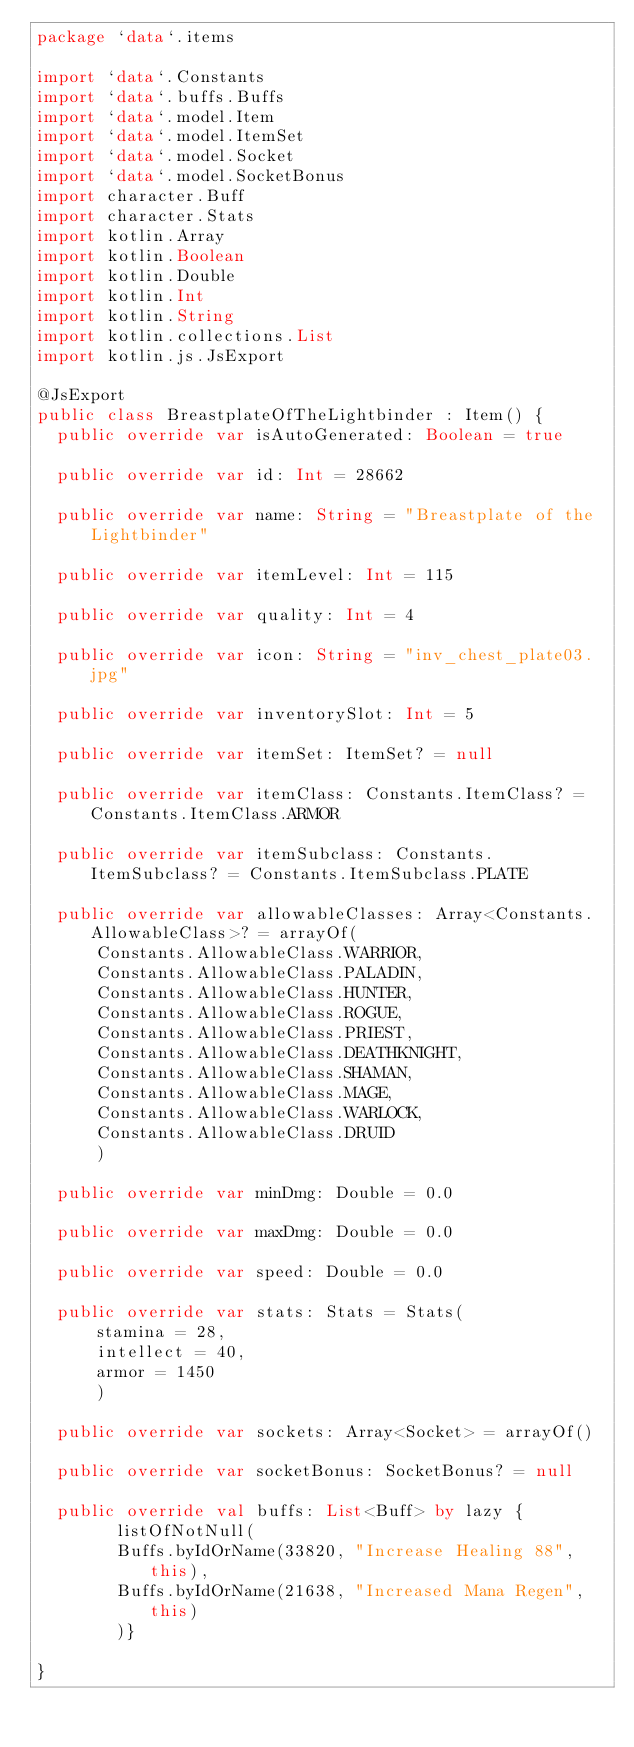<code> <loc_0><loc_0><loc_500><loc_500><_Kotlin_>package `data`.items

import `data`.Constants
import `data`.buffs.Buffs
import `data`.model.Item
import `data`.model.ItemSet
import `data`.model.Socket
import `data`.model.SocketBonus
import character.Buff
import character.Stats
import kotlin.Array
import kotlin.Boolean
import kotlin.Double
import kotlin.Int
import kotlin.String
import kotlin.collections.List
import kotlin.js.JsExport

@JsExport
public class BreastplateOfTheLightbinder : Item() {
  public override var isAutoGenerated: Boolean = true

  public override var id: Int = 28662

  public override var name: String = "Breastplate of the Lightbinder"

  public override var itemLevel: Int = 115

  public override var quality: Int = 4

  public override var icon: String = "inv_chest_plate03.jpg"

  public override var inventorySlot: Int = 5

  public override var itemSet: ItemSet? = null

  public override var itemClass: Constants.ItemClass? = Constants.ItemClass.ARMOR

  public override var itemSubclass: Constants.ItemSubclass? = Constants.ItemSubclass.PLATE

  public override var allowableClasses: Array<Constants.AllowableClass>? = arrayOf(
      Constants.AllowableClass.WARRIOR,
      Constants.AllowableClass.PALADIN,
      Constants.AllowableClass.HUNTER,
      Constants.AllowableClass.ROGUE,
      Constants.AllowableClass.PRIEST,
      Constants.AllowableClass.DEATHKNIGHT,
      Constants.AllowableClass.SHAMAN,
      Constants.AllowableClass.MAGE,
      Constants.AllowableClass.WARLOCK,
      Constants.AllowableClass.DRUID
      )

  public override var minDmg: Double = 0.0

  public override var maxDmg: Double = 0.0

  public override var speed: Double = 0.0

  public override var stats: Stats = Stats(
      stamina = 28,
      intellect = 40,
      armor = 1450
      )

  public override var sockets: Array<Socket> = arrayOf()

  public override var socketBonus: SocketBonus? = null

  public override val buffs: List<Buff> by lazy {
        listOfNotNull(
        Buffs.byIdOrName(33820, "Increase Healing 88", this),
        Buffs.byIdOrName(21638, "Increased Mana Regen", this)
        )}

}
</code> 